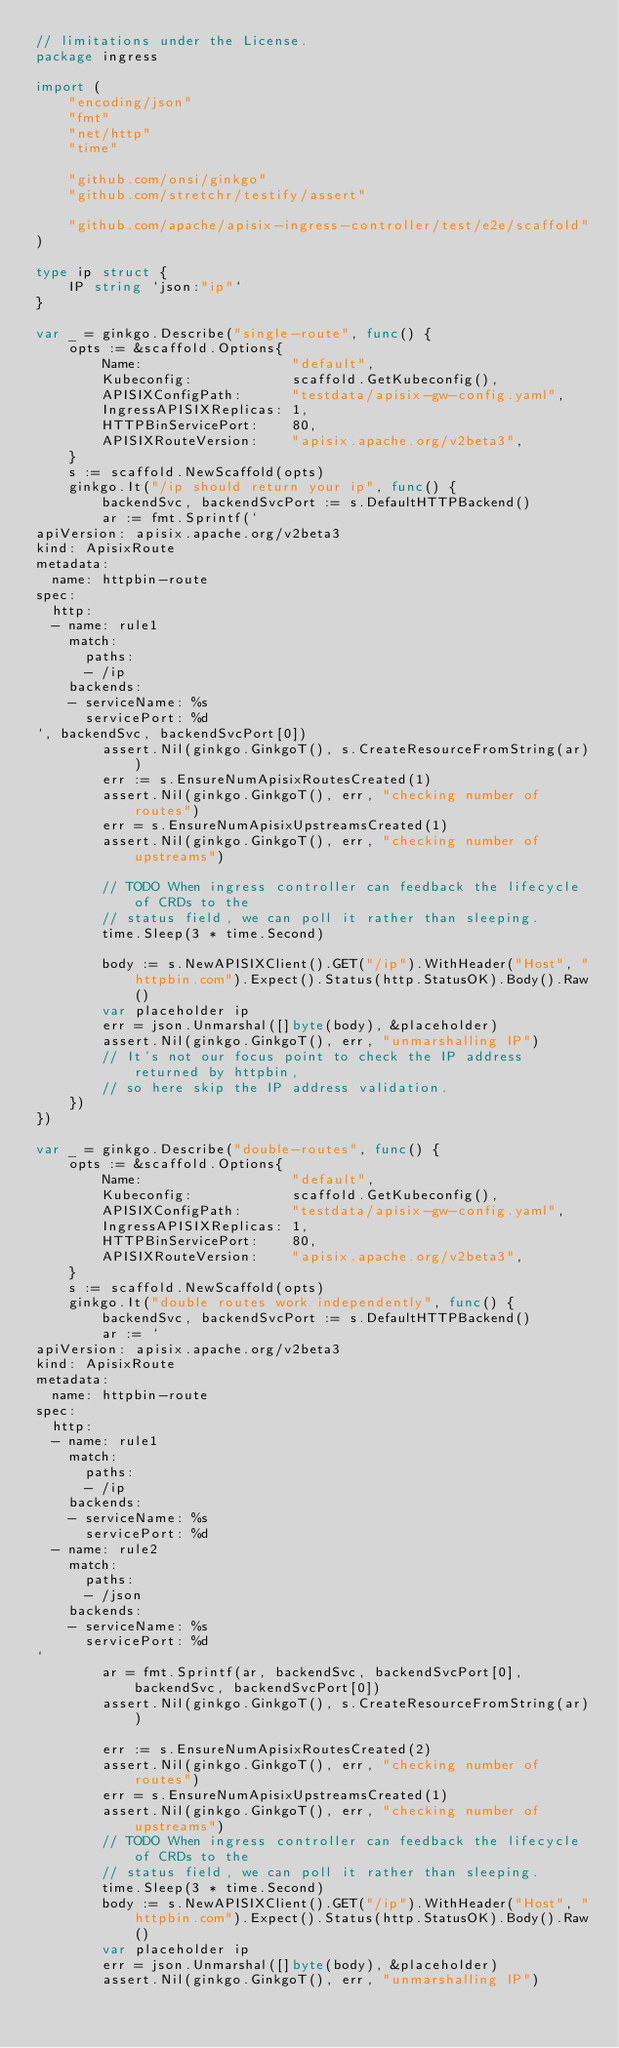<code> <loc_0><loc_0><loc_500><loc_500><_Go_>// limitations under the License.
package ingress

import (
	"encoding/json"
	"fmt"
	"net/http"
	"time"

	"github.com/onsi/ginkgo"
	"github.com/stretchr/testify/assert"

	"github.com/apache/apisix-ingress-controller/test/e2e/scaffold"
)

type ip struct {
	IP string `json:"ip"`
}

var _ = ginkgo.Describe("single-route", func() {
	opts := &scaffold.Options{
		Name:                  "default",
		Kubeconfig:            scaffold.GetKubeconfig(),
		APISIXConfigPath:      "testdata/apisix-gw-config.yaml",
		IngressAPISIXReplicas: 1,
		HTTPBinServicePort:    80,
		APISIXRouteVersion:    "apisix.apache.org/v2beta3",
	}
	s := scaffold.NewScaffold(opts)
	ginkgo.It("/ip should return your ip", func() {
		backendSvc, backendSvcPort := s.DefaultHTTPBackend()
		ar := fmt.Sprintf(`
apiVersion: apisix.apache.org/v2beta3
kind: ApisixRoute
metadata:
  name: httpbin-route
spec:
  http:
  - name: rule1
    match:
      paths:
      - /ip
    backends:
    - serviceName: %s
      servicePort: %d
`, backendSvc, backendSvcPort[0])
		assert.Nil(ginkgo.GinkgoT(), s.CreateResourceFromString(ar))
		err := s.EnsureNumApisixRoutesCreated(1)
		assert.Nil(ginkgo.GinkgoT(), err, "checking number of routes")
		err = s.EnsureNumApisixUpstreamsCreated(1)
		assert.Nil(ginkgo.GinkgoT(), err, "checking number of upstreams")

		// TODO When ingress controller can feedback the lifecycle of CRDs to the
		// status field, we can poll it rather than sleeping.
		time.Sleep(3 * time.Second)

		body := s.NewAPISIXClient().GET("/ip").WithHeader("Host", "httpbin.com").Expect().Status(http.StatusOK).Body().Raw()
		var placeholder ip
		err = json.Unmarshal([]byte(body), &placeholder)
		assert.Nil(ginkgo.GinkgoT(), err, "unmarshalling IP")
		// It's not our focus point to check the IP address returned by httpbin,
		// so here skip the IP address validation.
	})
})

var _ = ginkgo.Describe("double-routes", func() {
	opts := &scaffold.Options{
		Name:                  "default",
		Kubeconfig:            scaffold.GetKubeconfig(),
		APISIXConfigPath:      "testdata/apisix-gw-config.yaml",
		IngressAPISIXReplicas: 1,
		HTTPBinServicePort:    80,
		APISIXRouteVersion:    "apisix.apache.org/v2beta3",
	}
	s := scaffold.NewScaffold(opts)
	ginkgo.It("double routes work independently", func() {
		backendSvc, backendSvcPort := s.DefaultHTTPBackend()
		ar := `
apiVersion: apisix.apache.org/v2beta3
kind: ApisixRoute
metadata:
  name: httpbin-route
spec:
  http:
  - name: rule1
    match:
      paths:
      - /ip
    backends:
    - serviceName: %s
      servicePort: %d
  - name: rule2
    match:
      paths:
      - /json
    backends:
    - serviceName: %s
      servicePort: %d
`
		ar = fmt.Sprintf(ar, backendSvc, backendSvcPort[0], backendSvc, backendSvcPort[0])
		assert.Nil(ginkgo.GinkgoT(), s.CreateResourceFromString(ar))

		err := s.EnsureNumApisixRoutesCreated(2)
		assert.Nil(ginkgo.GinkgoT(), err, "checking number of routes")
		err = s.EnsureNumApisixUpstreamsCreated(1)
		assert.Nil(ginkgo.GinkgoT(), err, "checking number of upstreams")
		// TODO When ingress controller can feedback the lifecycle of CRDs to the
		// status field, we can poll it rather than sleeping.
		time.Sleep(3 * time.Second)
		body := s.NewAPISIXClient().GET("/ip").WithHeader("Host", "httpbin.com").Expect().Status(http.StatusOK).Body().Raw()
		var placeholder ip
		err = json.Unmarshal([]byte(body), &placeholder)
		assert.Nil(ginkgo.GinkgoT(), err, "unmarshalling IP")
</code> 